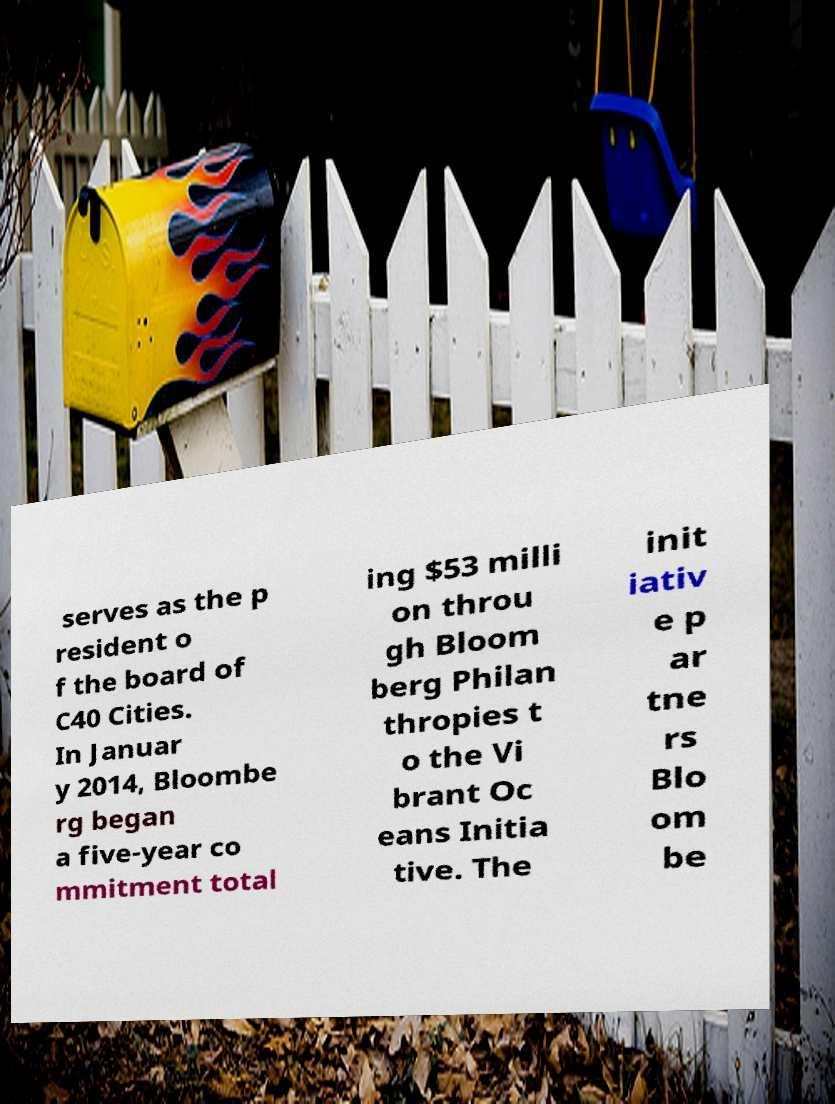There's text embedded in this image that I need extracted. Can you transcribe it verbatim? serves as the p resident o f the board of C40 Cities. In Januar y 2014, Bloombe rg began a five-year co mmitment total ing $53 milli on throu gh Bloom berg Philan thropies t o the Vi brant Oc eans Initia tive. The init iativ e p ar tne rs Blo om be 